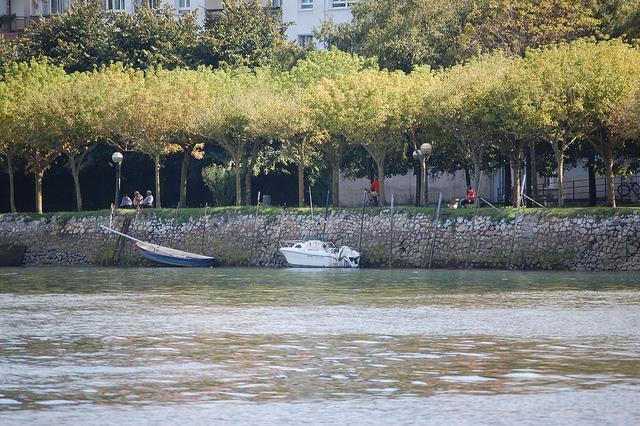What is the black rectangular object in front of the blue boat?
Select the accurate response from the four choices given to answer the question.
Options: Pole, hose, fence, ladder. Ladder. 